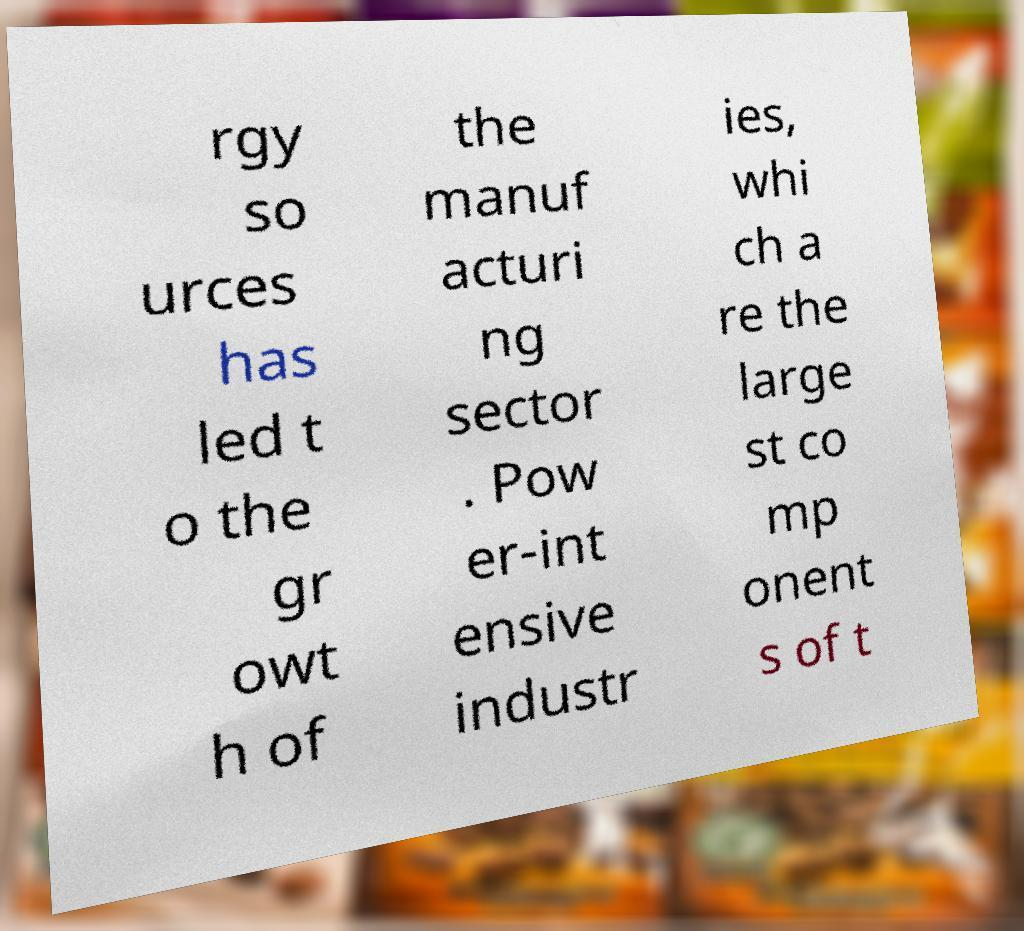Could you assist in decoding the text presented in this image and type it out clearly? rgy so urces has led t o the gr owt h of the manuf acturi ng sector . Pow er-int ensive industr ies, whi ch a re the large st co mp onent s of t 